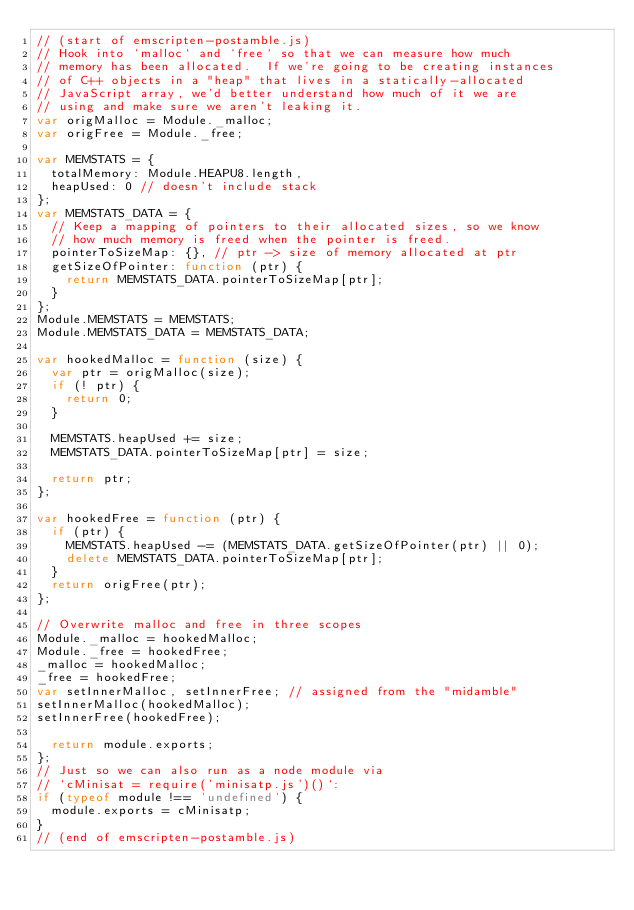<code> <loc_0><loc_0><loc_500><loc_500><_JavaScript_>// (start of emscripten-postamble.js)
// Hook into `malloc` and `free` so that we can measure how much
// memory has been allocated.  If we're going to be creating instances
// of C++ objects in a "heap" that lives in a statically-allocated
// JavaScript array, we'd better understand how much of it we are
// using and make sure we aren't leaking it.
var origMalloc = Module._malloc;
var origFree = Module._free;

var MEMSTATS = {
  totalMemory: Module.HEAPU8.length,
  heapUsed: 0 // doesn't include stack
};
var MEMSTATS_DATA = {
  // Keep a mapping of pointers to their allocated sizes, so we know
  // how much memory is freed when the pointer is freed.
  pointerToSizeMap: {}, // ptr -> size of memory allocated at ptr
  getSizeOfPointer: function (ptr) {
    return MEMSTATS_DATA.pointerToSizeMap[ptr];
  }
};
Module.MEMSTATS = MEMSTATS;
Module.MEMSTATS_DATA = MEMSTATS_DATA;

var hookedMalloc = function (size) {
  var ptr = origMalloc(size);
  if (! ptr) {
    return 0;
  }

  MEMSTATS.heapUsed += size;
  MEMSTATS_DATA.pointerToSizeMap[ptr] = size;

  return ptr;
};

var hookedFree = function (ptr) {
  if (ptr) {
    MEMSTATS.heapUsed -= (MEMSTATS_DATA.getSizeOfPointer(ptr) || 0);
    delete MEMSTATS_DATA.pointerToSizeMap[ptr];
  }
  return origFree(ptr);
};

// Overwrite malloc and free in three scopes
Module._malloc = hookedMalloc;
Module._free = hookedFree;
_malloc = hookedMalloc;
_free = hookedFree;
var setInnerMalloc, setInnerFree; // assigned from the "midamble"
setInnerMalloc(hookedMalloc);
setInnerFree(hookedFree);

  return module.exports;
};
// Just so we can also run as a node module via
// `cMinisat = require('minisatp.js')()`:
if (typeof module !== 'undefined') {
  module.exports = cMinisatp;
}
// (end of emscripten-postamble.js)
</code> 